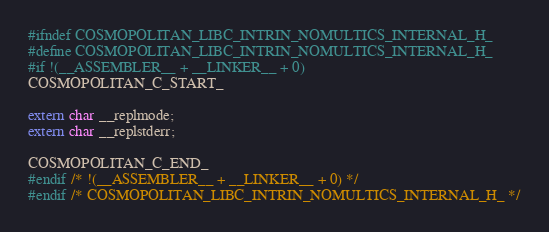Convert code to text. <code><loc_0><loc_0><loc_500><loc_500><_C_>#ifndef COSMOPOLITAN_LIBC_INTRIN_NOMULTICS_INTERNAL_H_
#define COSMOPOLITAN_LIBC_INTRIN_NOMULTICS_INTERNAL_H_
#if !(__ASSEMBLER__ + __LINKER__ + 0)
COSMOPOLITAN_C_START_

extern char __replmode;
extern char __replstderr;

COSMOPOLITAN_C_END_
#endif /* !(__ASSEMBLER__ + __LINKER__ + 0) */
#endif /* COSMOPOLITAN_LIBC_INTRIN_NOMULTICS_INTERNAL_H_ */
</code> 